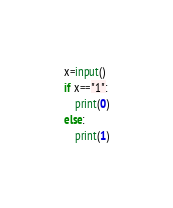<code> <loc_0><loc_0><loc_500><loc_500><_Python_>x=input()
if x=="1":
    print(0)
else:
    print(1)</code> 